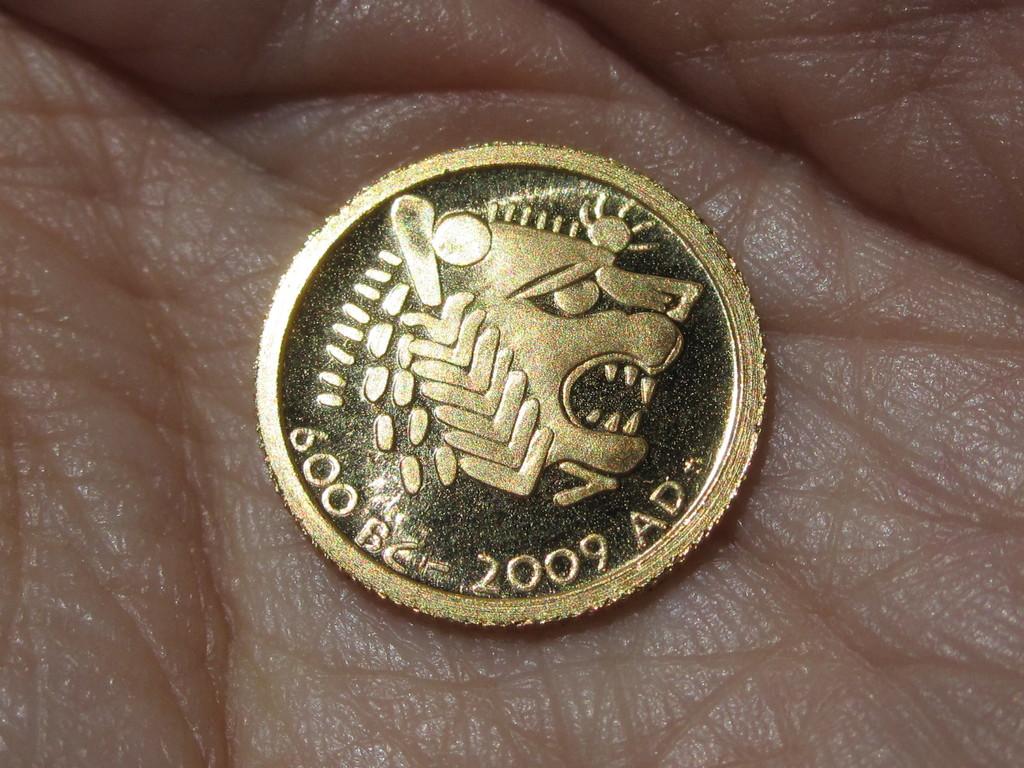What year ad is this coin?
Your response must be concise. 2009. What year bc is shown on the coin?
Your answer should be compact. 600. 